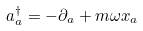Convert formula to latex. <formula><loc_0><loc_0><loc_500><loc_500>a _ { a } ^ { \dagger } = - \partial _ { a } + m \omega x _ { a }</formula> 